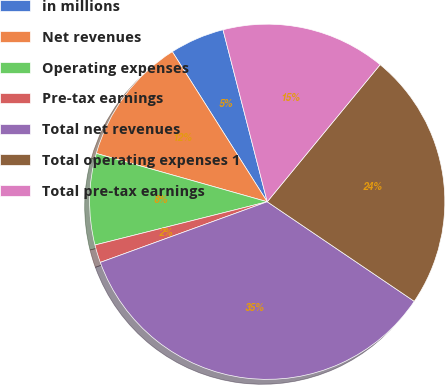Convert chart to OTSL. <chart><loc_0><loc_0><loc_500><loc_500><pie_chart><fcel>in millions<fcel>Net revenues<fcel>Operating expenses<fcel>Pre-tax earnings<fcel>Total net revenues<fcel>Total operating expenses 1<fcel>Total pre-tax earnings<nl><fcel>4.97%<fcel>11.64%<fcel>8.3%<fcel>1.63%<fcel>34.98%<fcel>23.51%<fcel>14.97%<nl></chart> 